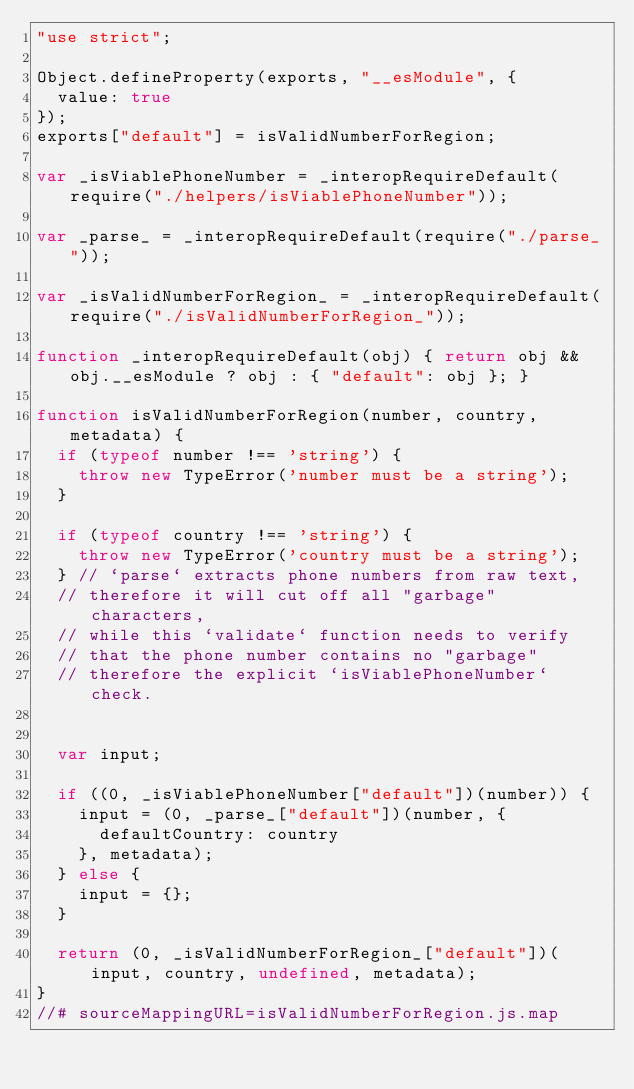<code> <loc_0><loc_0><loc_500><loc_500><_JavaScript_>"use strict";

Object.defineProperty(exports, "__esModule", {
  value: true
});
exports["default"] = isValidNumberForRegion;

var _isViablePhoneNumber = _interopRequireDefault(require("./helpers/isViablePhoneNumber"));

var _parse_ = _interopRequireDefault(require("./parse_"));

var _isValidNumberForRegion_ = _interopRequireDefault(require("./isValidNumberForRegion_"));

function _interopRequireDefault(obj) { return obj && obj.__esModule ? obj : { "default": obj }; }

function isValidNumberForRegion(number, country, metadata) {
  if (typeof number !== 'string') {
    throw new TypeError('number must be a string');
  }

  if (typeof country !== 'string') {
    throw new TypeError('country must be a string');
  } // `parse` extracts phone numbers from raw text,
  // therefore it will cut off all "garbage" characters,
  // while this `validate` function needs to verify
  // that the phone number contains no "garbage"
  // therefore the explicit `isViablePhoneNumber` check.


  var input;

  if ((0, _isViablePhoneNumber["default"])(number)) {
    input = (0, _parse_["default"])(number, {
      defaultCountry: country
    }, metadata);
  } else {
    input = {};
  }

  return (0, _isValidNumberForRegion_["default"])(input, country, undefined, metadata);
}
//# sourceMappingURL=isValidNumberForRegion.js.map</code> 